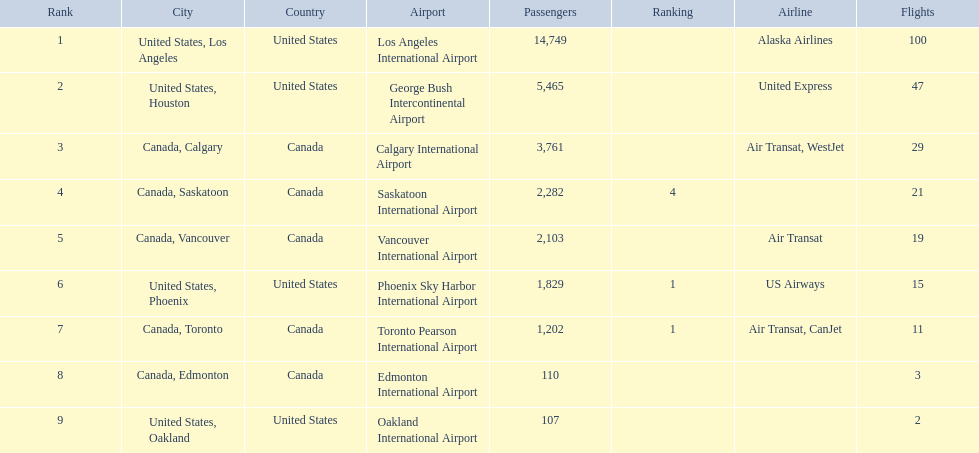What are the cities that are associated with the playa de oro international airport? United States, Los Angeles, United States, Houston, Canada, Calgary, Canada, Saskatoon, Canada, Vancouver, United States, Phoenix, Canada, Toronto, Canada, Edmonton, United States, Oakland. What is uniteed states, los angeles passenger count? 14,749. What other cities passenger count would lead to 19,000 roughly when combined with previous los angeles? Canada, Calgary. 